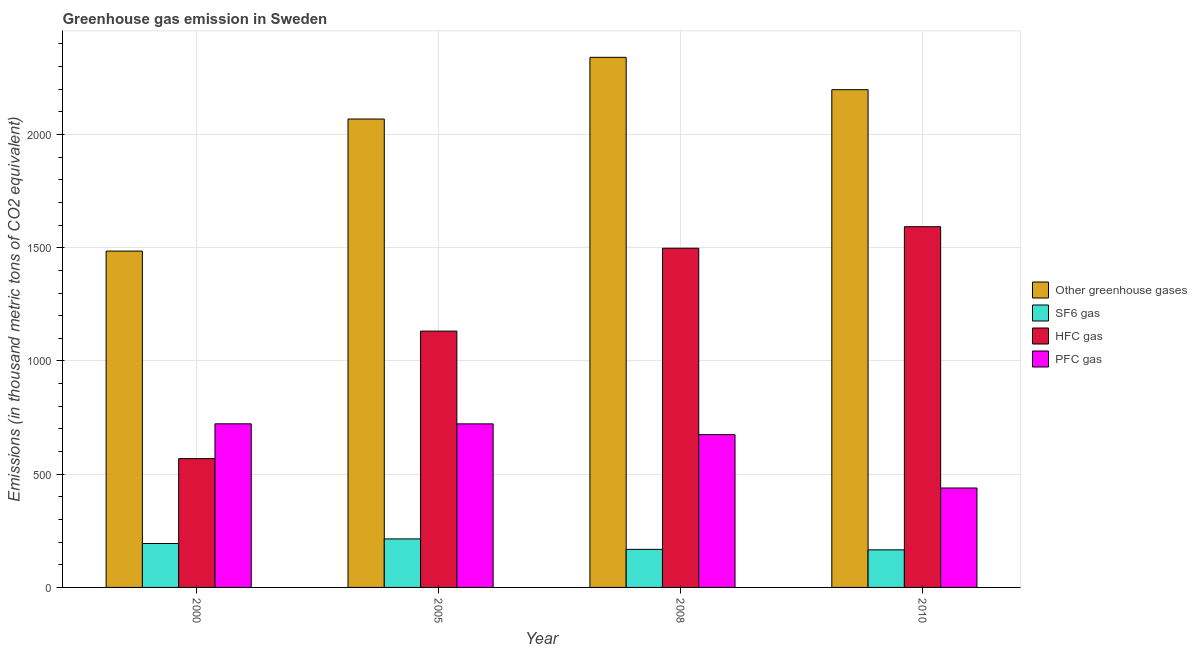How many different coloured bars are there?
Provide a short and direct response. 4. How many groups of bars are there?
Offer a very short reply. 4. Are the number of bars on each tick of the X-axis equal?
Keep it short and to the point. Yes. What is the emission of pfc gas in 2008?
Your answer should be very brief. 674.8. Across all years, what is the maximum emission of pfc gas?
Provide a succinct answer. 722.5. Across all years, what is the minimum emission of pfc gas?
Make the answer very short. 439. In which year was the emission of hfc gas maximum?
Provide a short and direct response. 2010. In which year was the emission of hfc gas minimum?
Ensure brevity in your answer.  2000. What is the total emission of hfc gas in the graph?
Your answer should be compact. 4791.7. What is the difference between the emission of greenhouse gases in 2000 and that in 2005?
Provide a short and direct response. -583.1. What is the difference between the emission of pfc gas in 2005 and the emission of sf6 gas in 2008?
Give a very brief answer. 47.5. What is the average emission of greenhouse gases per year?
Offer a terse response. 2023.15. In the year 2010, what is the difference between the emission of pfc gas and emission of sf6 gas?
Offer a terse response. 0. What is the ratio of the emission of greenhouse gases in 2008 to that in 2010?
Your response must be concise. 1.07. Is the emission of greenhouse gases in 2008 less than that in 2010?
Your answer should be very brief. No. Is the difference between the emission of pfc gas in 2000 and 2008 greater than the difference between the emission of hfc gas in 2000 and 2008?
Make the answer very short. No. What is the difference between the highest and the second highest emission of greenhouse gases?
Your answer should be very brief. 142.9. What is the difference between the highest and the lowest emission of pfc gas?
Your response must be concise. 283.5. In how many years, is the emission of hfc gas greater than the average emission of hfc gas taken over all years?
Ensure brevity in your answer.  2. Is the sum of the emission of hfc gas in 2000 and 2008 greater than the maximum emission of greenhouse gases across all years?
Provide a succinct answer. Yes. What does the 4th bar from the left in 2010 represents?
Offer a very short reply. PFC gas. What does the 1st bar from the right in 2000 represents?
Ensure brevity in your answer.  PFC gas. How many bars are there?
Ensure brevity in your answer.  16. Are all the bars in the graph horizontal?
Offer a terse response. No. Does the graph contain grids?
Ensure brevity in your answer.  Yes. What is the title of the graph?
Provide a succinct answer. Greenhouse gas emission in Sweden. What is the label or title of the X-axis?
Offer a terse response. Year. What is the label or title of the Y-axis?
Your answer should be compact. Emissions (in thousand metric tons of CO2 equivalent). What is the Emissions (in thousand metric tons of CO2 equivalent) of Other greenhouse gases in 2000?
Your response must be concise. 1485.3. What is the Emissions (in thousand metric tons of CO2 equivalent) of SF6 gas in 2000?
Your answer should be compact. 194. What is the Emissions (in thousand metric tons of CO2 equivalent) in HFC gas in 2000?
Your answer should be very brief. 568.8. What is the Emissions (in thousand metric tons of CO2 equivalent) of PFC gas in 2000?
Offer a terse response. 722.5. What is the Emissions (in thousand metric tons of CO2 equivalent) in Other greenhouse gases in 2005?
Your answer should be compact. 2068.4. What is the Emissions (in thousand metric tons of CO2 equivalent) in SF6 gas in 2005?
Make the answer very short. 214.2. What is the Emissions (in thousand metric tons of CO2 equivalent) in HFC gas in 2005?
Keep it short and to the point. 1131.9. What is the Emissions (in thousand metric tons of CO2 equivalent) in PFC gas in 2005?
Your response must be concise. 722.3. What is the Emissions (in thousand metric tons of CO2 equivalent) in Other greenhouse gases in 2008?
Give a very brief answer. 2340.9. What is the Emissions (in thousand metric tons of CO2 equivalent) of SF6 gas in 2008?
Provide a short and direct response. 168.1. What is the Emissions (in thousand metric tons of CO2 equivalent) in HFC gas in 2008?
Keep it short and to the point. 1498. What is the Emissions (in thousand metric tons of CO2 equivalent) of PFC gas in 2008?
Offer a terse response. 674.8. What is the Emissions (in thousand metric tons of CO2 equivalent) in Other greenhouse gases in 2010?
Offer a terse response. 2198. What is the Emissions (in thousand metric tons of CO2 equivalent) in SF6 gas in 2010?
Keep it short and to the point. 166. What is the Emissions (in thousand metric tons of CO2 equivalent) in HFC gas in 2010?
Offer a very short reply. 1593. What is the Emissions (in thousand metric tons of CO2 equivalent) of PFC gas in 2010?
Keep it short and to the point. 439. Across all years, what is the maximum Emissions (in thousand metric tons of CO2 equivalent) in Other greenhouse gases?
Offer a terse response. 2340.9. Across all years, what is the maximum Emissions (in thousand metric tons of CO2 equivalent) of SF6 gas?
Provide a short and direct response. 214.2. Across all years, what is the maximum Emissions (in thousand metric tons of CO2 equivalent) of HFC gas?
Offer a very short reply. 1593. Across all years, what is the maximum Emissions (in thousand metric tons of CO2 equivalent) of PFC gas?
Ensure brevity in your answer.  722.5. Across all years, what is the minimum Emissions (in thousand metric tons of CO2 equivalent) in Other greenhouse gases?
Your answer should be very brief. 1485.3. Across all years, what is the minimum Emissions (in thousand metric tons of CO2 equivalent) in SF6 gas?
Keep it short and to the point. 166. Across all years, what is the minimum Emissions (in thousand metric tons of CO2 equivalent) of HFC gas?
Keep it short and to the point. 568.8. Across all years, what is the minimum Emissions (in thousand metric tons of CO2 equivalent) in PFC gas?
Your answer should be very brief. 439. What is the total Emissions (in thousand metric tons of CO2 equivalent) of Other greenhouse gases in the graph?
Ensure brevity in your answer.  8092.6. What is the total Emissions (in thousand metric tons of CO2 equivalent) in SF6 gas in the graph?
Offer a terse response. 742.3. What is the total Emissions (in thousand metric tons of CO2 equivalent) of HFC gas in the graph?
Provide a short and direct response. 4791.7. What is the total Emissions (in thousand metric tons of CO2 equivalent) in PFC gas in the graph?
Offer a very short reply. 2558.6. What is the difference between the Emissions (in thousand metric tons of CO2 equivalent) in Other greenhouse gases in 2000 and that in 2005?
Give a very brief answer. -583.1. What is the difference between the Emissions (in thousand metric tons of CO2 equivalent) of SF6 gas in 2000 and that in 2005?
Make the answer very short. -20.2. What is the difference between the Emissions (in thousand metric tons of CO2 equivalent) in HFC gas in 2000 and that in 2005?
Make the answer very short. -563.1. What is the difference between the Emissions (in thousand metric tons of CO2 equivalent) of PFC gas in 2000 and that in 2005?
Provide a succinct answer. 0.2. What is the difference between the Emissions (in thousand metric tons of CO2 equivalent) in Other greenhouse gases in 2000 and that in 2008?
Your answer should be compact. -855.6. What is the difference between the Emissions (in thousand metric tons of CO2 equivalent) of SF6 gas in 2000 and that in 2008?
Your answer should be very brief. 25.9. What is the difference between the Emissions (in thousand metric tons of CO2 equivalent) in HFC gas in 2000 and that in 2008?
Provide a short and direct response. -929.2. What is the difference between the Emissions (in thousand metric tons of CO2 equivalent) of PFC gas in 2000 and that in 2008?
Keep it short and to the point. 47.7. What is the difference between the Emissions (in thousand metric tons of CO2 equivalent) in Other greenhouse gases in 2000 and that in 2010?
Give a very brief answer. -712.7. What is the difference between the Emissions (in thousand metric tons of CO2 equivalent) of SF6 gas in 2000 and that in 2010?
Your answer should be very brief. 28. What is the difference between the Emissions (in thousand metric tons of CO2 equivalent) of HFC gas in 2000 and that in 2010?
Give a very brief answer. -1024.2. What is the difference between the Emissions (in thousand metric tons of CO2 equivalent) of PFC gas in 2000 and that in 2010?
Your response must be concise. 283.5. What is the difference between the Emissions (in thousand metric tons of CO2 equivalent) of Other greenhouse gases in 2005 and that in 2008?
Keep it short and to the point. -272.5. What is the difference between the Emissions (in thousand metric tons of CO2 equivalent) of SF6 gas in 2005 and that in 2008?
Ensure brevity in your answer.  46.1. What is the difference between the Emissions (in thousand metric tons of CO2 equivalent) in HFC gas in 2005 and that in 2008?
Give a very brief answer. -366.1. What is the difference between the Emissions (in thousand metric tons of CO2 equivalent) in PFC gas in 2005 and that in 2008?
Keep it short and to the point. 47.5. What is the difference between the Emissions (in thousand metric tons of CO2 equivalent) of Other greenhouse gases in 2005 and that in 2010?
Offer a terse response. -129.6. What is the difference between the Emissions (in thousand metric tons of CO2 equivalent) in SF6 gas in 2005 and that in 2010?
Your answer should be compact. 48.2. What is the difference between the Emissions (in thousand metric tons of CO2 equivalent) of HFC gas in 2005 and that in 2010?
Provide a short and direct response. -461.1. What is the difference between the Emissions (in thousand metric tons of CO2 equivalent) of PFC gas in 2005 and that in 2010?
Provide a short and direct response. 283.3. What is the difference between the Emissions (in thousand metric tons of CO2 equivalent) in Other greenhouse gases in 2008 and that in 2010?
Your answer should be very brief. 142.9. What is the difference between the Emissions (in thousand metric tons of CO2 equivalent) in HFC gas in 2008 and that in 2010?
Ensure brevity in your answer.  -95. What is the difference between the Emissions (in thousand metric tons of CO2 equivalent) of PFC gas in 2008 and that in 2010?
Your response must be concise. 235.8. What is the difference between the Emissions (in thousand metric tons of CO2 equivalent) in Other greenhouse gases in 2000 and the Emissions (in thousand metric tons of CO2 equivalent) in SF6 gas in 2005?
Ensure brevity in your answer.  1271.1. What is the difference between the Emissions (in thousand metric tons of CO2 equivalent) of Other greenhouse gases in 2000 and the Emissions (in thousand metric tons of CO2 equivalent) of HFC gas in 2005?
Provide a succinct answer. 353.4. What is the difference between the Emissions (in thousand metric tons of CO2 equivalent) of Other greenhouse gases in 2000 and the Emissions (in thousand metric tons of CO2 equivalent) of PFC gas in 2005?
Offer a very short reply. 763. What is the difference between the Emissions (in thousand metric tons of CO2 equivalent) of SF6 gas in 2000 and the Emissions (in thousand metric tons of CO2 equivalent) of HFC gas in 2005?
Provide a succinct answer. -937.9. What is the difference between the Emissions (in thousand metric tons of CO2 equivalent) of SF6 gas in 2000 and the Emissions (in thousand metric tons of CO2 equivalent) of PFC gas in 2005?
Keep it short and to the point. -528.3. What is the difference between the Emissions (in thousand metric tons of CO2 equivalent) in HFC gas in 2000 and the Emissions (in thousand metric tons of CO2 equivalent) in PFC gas in 2005?
Ensure brevity in your answer.  -153.5. What is the difference between the Emissions (in thousand metric tons of CO2 equivalent) of Other greenhouse gases in 2000 and the Emissions (in thousand metric tons of CO2 equivalent) of SF6 gas in 2008?
Offer a very short reply. 1317.2. What is the difference between the Emissions (in thousand metric tons of CO2 equivalent) in Other greenhouse gases in 2000 and the Emissions (in thousand metric tons of CO2 equivalent) in HFC gas in 2008?
Keep it short and to the point. -12.7. What is the difference between the Emissions (in thousand metric tons of CO2 equivalent) of Other greenhouse gases in 2000 and the Emissions (in thousand metric tons of CO2 equivalent) of PFC gas in 2008?
Your answer should be very brief. 810.5. What is the difference between the Emissions (in thousand metric tons of CO2 equivalent) of SF6 gas in 2000 and the Emissions (in thousand metric tons of CO2 equivalent) of HFC gas in 2008?
Your answer should be very brief. -1304. What is the difference between the Emissions (in thousand metric tons of CO2 equivalent) in SF6 gas in 2000 and the Emissions (in thousand metric tons of CO2 equivalent) in PFC gas in 2008?
Your answer should be very brief. -480.8. What is the difference between the Emissions (in thousand metric tons of CO2 equivalent) of HFC gas in 2000 and the Emissions (in thousand metric tons of CO2 equivalent) of PFC gas in 2008?
Your answer should be very brief. -106. What is the difference between the Emissions (in thousand metric tons of CO2 equivalent) in Other greenhouse gases in 2000 and the Emissions (in thousand metric tons of CO2 equivalent) in SF6 gas in 2010?
Make the answer very short. 1319.3. What is the difference between the Emissions (in thousand metric tons of CO2 equivalent) in Other greenhouse gases in 2000 and the Emissions (in thousand metric tons of CO2 equivalent) in HFC gas in 2010?
Offer a terse response. -107.7. What is the difference between the Emissions (in thousand metric tons of CO2 equivalent) in Other greenhouse gases in 2000 and the Emissions (in thousand metric tons of CO2 equivalent) in PFC gas in 2010?
Ensure brevity in your answer.  1046.3. What is the difference between the Emissions (in thousand metric tons of CO2 equivalent) of SF6 gas in 2000 and the Emissions (in thousand metric tons of CO2 equivalent) of HFC gas in 2010?
Your answer should be very brief. -1399. What is the difference between the Emissions (in thousand metric tons of CO2 equivalent) in SF6 gas in 2000 and the Emissions (in thousand metric tons of CO2 equivalent) in PFC gas in 2010?
Your answer should be compact. -245. What is the difference between the Emissions (in thousand metric tons of CO2 equivalent) in HFC gas in 2000 and the Emissions (in thousand metric tons of CO2 equivalent) in PFC gas in 2010?
Give a very brief answer. 129.8. What is the difference between the Emissions (in thousand metric tons of CO2 equivalent) of Other greenhouse gases in 2005 and the Emissions (in thousand metric tons of CO2 equivalent) of SF6 gas in 2008?
Make the answer very short. 1900.3. What is the difference between the Emissions (in thousand metric tons of CO2 equivalent) of Other greenhouse gases in 2005 and the Emissions (in thousand metric tons of CO2 equivalent) of HFC gas in 2008?
Keep it short and to the point. 570.4. What is the difference between the Emissions (in thousand metric tons of CO2 equivalent) of Other greenhouse gases in 2005 and the Emissions (in thousand metric tons of CO2 equivalent) of PFC gas in 2008?
Offer a terse response. 1393.6. What is the difference between the Emissions (in thousand metric tons of CO2 equivalent) of SF6 gas in 2005 and the Emissions (in thousand metric tons of CO2 equivalent) of HFC gas in 2008?
Ensure brevity in your answer.  -1283.8. What is the difference between the Emissions (in thousand metric tons of CO2 equivalent) of SF6 gas in 2005 and the Emissions (in thousand metric tons of CO2 equivalent) of PFC gas in 2008?
Ensure brevity in your answer.  -460.6. What is the difference between the Emissions (in thousand metric tons of CO2 equivalent) of HFC gas in 2005 and the Emissions (in thousand metric tons of CO2 equivalent) of PFC gas in 2008?
Keep it short and to the point. 457.1. What is the difference between the Emissions (in thousand metric tons of CO2 equivalent) of Other greenhouse gases in 2005 and the Emissions (in thousand metric tons of CO2 equivalent) of SF6 gas in 2010?
Your answer should be compact. 1902.4. What is the difference between the Emissions (in thousand metric tons of CO2 equivalent) of Other greenhouse gases in 2005 and the Emissions (in thousand metric tons of CO2 equivalent) of HFC gas in 2010?
Provide a succinct answer. 475.4. What is the difference between the Emissions (in thousand metric tons of CO2 equivalent) of Other greenhouse gases in 2005 and the Emissions (in thousand metric tons of CO2 equivalent) of PFC gas in 2010?
Provide a short and direct response. 1629.4. What is the difference between the Emissions (in thousand metric tons of CO2 equivalent) in SF6 gas in 2005 and the Emissions (in thousand metric tons of CO2 equivalent) in HFC gas in 2010?
Offer a very short reply. -1378.8. What is the difference between the Emissions (in thousand metric tons of CO2 equivalent) of SF6 gas in 2005 and the Emissions (in thousand metric tons of CO2 equivalent) of PFC gas in 2010?
Your response must be concise. -224.8. What is the difference between the Emissions (in thousand metric tons of CO2 equivalent) in HFC gas in 2005 and the Emissions (in thousand metric tons of CO2 equivalent) in PFC gas in 2010?
Make the answer very short. 692.9. What is the difference between the Emissions (in thousand metric tons of CO2 equivalent) in Other greenhouse gases in 2008 and the Emissions (in thousand metric tons of CO2 equivalent) in SF6 gas in 2010?
Your answer should be very brief. 2174.9. What is the difference between the Emissions (in thousand metric tons of CO2 equivalent) in Other greenhouse gases in 2008 and the Emissions (in thousand metric tons of CO2 equivalent) in HFC gas in 2010?
Give a very brief answer. 747.9. What is the difference between the Emissions (in thousand metric tons of CO2 equivalent) of Other greenhouse gases in 2008 and the Emissions (in thousand metric tons of CO2 equivalent) of PFC gas in 2010?
Make the answer very short. 1901.9. What is the difference between the Emissions (in thousand metric tons of CO2 equivalent) of SF6 gas in 2008 and the Emissions (in thousand metric tons of CO2 equivalent) of HFC gas in 2010?
Offer a very short reply. -1424.9. What is the difference between the Emissions (in thousand metric tons of CO2 equivalent) in SF6 gas in 2008 and the Emissions (in thousand metric tons of CO2 equivalent) in PFC gas in 2010?
Provide a short and direct response. -270.9. What is the difference between the Emissions (in thousand metric tons of CO2 equivalent) in HFC gas in 2008 and the Emissions (in thousand metric tons of CO2 equivalent) in PFC gas in 2010?
Your answer should be very brief. 1059. What is the average Emissions (in thousand metric tons of CO2 equivalent) of Other greenhouse gases per year?
Your response must be concise. 2023.15. What is the average Emissions (in thousand metric tons of CO2 equivalent) in SF6 gas per year?
Make the answer very short. 185.57. What is the average Emissions (in thousand metric tons of CO2 equivalent) in HFC gas per year?
Give a very brief answer. 1197.92. What is the average Emissions (in thousand metric tons of CO2 equivalent) of PFC gas per year?
Ensure brevity in your answer.  639.65. In the year 2000, what is the difference between the Emissions (in thousand metric tons of CO2 equivalent) of Other greenhouse gases and Emissions (in thousand metric tons of CO2 equivalent) of SF6 gas?
Keep it short and to the point. 1291.3. In the year 2000, what is the difference between the Emissions (in thousand metric tons of CO2 equivalent) in Other greenhouse gases and Emissions (in thousand metric tons of CO2 equivalent) in HFC gas?
Make the answer very short. 916.5. In the year 2000, what is the difference between the Emissions (in thousand metric tons of CO2 equivalent) of Other greenhouse gases and Emissions (in thousand metric tons of CO2 equivalent) of PFC gas?
Ensure brevity in your answer.  762.8. In the year 2000, what is the difference between the Emissions (in thousand metric tons of CO2 equivalent) of SF6 gas and Emissions (in thousand metric tons of CO2 equivalent) of HFC gas?
Your answer should be very brief. -374.8. In the year 2000, what is the difference between the Emissions (in thousand metric tons of CO2 equivalent) in SF6 gas and Emissions (in thousand metric tons of CO2 equivalent) in PFC gas?
Your answer should be compact. -528.5. In the year 2000, what is the difference between the Emissions (in thousand metric tons of CO2 equivalent) of HFC gas and Emissions (in thousand metric tons of CO2 equivalent) of PFC gas?
Provide a succinct answer. -153.7. In the year 2005, what is the difference between the Emissions (in thousand metric tons of CO2 equivalent) in Other greenhouse gases and Emissions (in thousand metric tons of CO2 equivalent) in SF6 gas?
Your answer should be very brief. 1854.2. In the year 2005, what is the difference between the Emissions (in thousand metric tons of CO2 equivalent) of Other greenhouse gases and Emissions (in thousand metric tons of CO2 equivalent) of HFC gas?
Offer a terse response. 936.5. In the year 2005, what is the difference between the Emissions (in thousand metric tons of CO2 equivalent) in Other greenhouse gases and Emissions (in thousand metric tons of CO2 equivalent) in PFC gas?
Your answer should be very brief. 1346.1. In the year 2005, what is the difference between the Emissions (in thousand metric tons of CO2 equivalent) of SF6 gas and Emissions (in thousand metric tons of CO2 equivalent) of HFC gas?
Provide a short and direct response. -917.7. In the year 2005, what is the difference between the Emissions (in thousand metric tons of CO2 equivalent) in SF6 gas and Emissions (in thousand metric tons of CO2 equivalent) in PFC gas?
Your answer should be very brief. -508.1. In the year 2005, what is the difference between the Emissions (in thousand metric tons of CO2 equivalent) in HFC gas and Emissions (in thousand metric tons of CO2 equivalent) in PFC gas?
Offer a terse response. 409.6. In the year 2008, what is the difference between the Emissions (in thousand metric tons of CO2 equivalent) of Other greenhouse gases and Emissions (in thousand metric tons of CO2 equivalent) of SF6 gas?
Offer a very short reply. 2172.8. In the year 2008, what is the difference between the Emissions (in thousand metric tons of CO2 equivalent) in Other greenhouse gases and Emissions (in thousand metric tons of CO2 equivalent) in HFC gas?
Offer a terse response. 842.9. In the year 2008, what is the difference between the Emissions (in thousand metric tons of CO2 equivalent) in Other greenhouse gases and Emissions (in thousand metric tons of CO2 equivalent) in PFC gas?
Provide a short and direct response. 1666.1. In the year 2008, what is the difference between the Emissions (in thousand metric tons of CO2 equivalent) of SF6 gas and Emissions (in thousand metric tons of CO2 equivalent) of HFC gas?
Keep it short and to the point. -1329.9. In the year 2008, what is the difference between the Emissions (in thousand metric tons of CO2 equivalent) in SF6 gas and Emissions (in thousand metric tons of CO2 equivalent) in PFC gas?
Your response must be concise. -506.7. In the year 2008, what is the difference between the Emissions (in thousand metric tons of CO2 equivalent) in HFC gas and Emissions (in thousand metric tons of CO2 equivalent) in PFC gas?
Provide a succinct answer. 823.2. In the year 2010, what is the difference between the Emissions (in thousand metric tons of CO2 equivalent) of Other greenhouse gases and Emissions (in thousand metric tons of CO2 equivalent) of SF6 gas?
Keep it short and to the point. 2032. In the year 2010, what is the difference between the Emissions (in thousand metric tons of CO2 equivalent) of Other greenhouse gases and Emissions (in thousand metric tons of CO2 equivalent) of HFC gas?
Your response must be concise. 605. In the year 2010, what is the difference between the Emissions (in thousand metric tons of CO2 equivalent) in Other greenhouse gases and Emissions (in thousand metric tons of CO2 equivalent) in PFC gas?
Ensure brevity in your answer.  1759. In the year 2010, what is the difference between the Emissions (in thousand metric tons of CO2 equivalent) in SF6 gas and Emissions (in thousand metric tons of CO2 equivalent) in HFC gas?
Provide a succinct answer. -1427. In the year 2010, what is the difference between the Emissions (in thousand metric tons of CO2 equivalent) in SF6 gas and Emissions (in thousand metric tons of CO2 equivalent) in PFC gas?
Offer a very short reply. -273. In the year 2010, what is the difference between the Emissions (in thousand metric tons of CO2 equivalent) of HFC gas and Emissions (in thousand metric tons of CO2 equivalent) of PFC gas?
Offer a very short reply. 1154. What is the ratio of the Emissions (in thousand metric tons of CO2 equivalent) in Other greenhouse gases in 2000 to that in 2005?
Keep it short and to the point. 0.72. What is the ratio of the Emissions (in thousand metric tons of CO2 equivalent) of SF6 gas in 2000 to that in 2005?
Give a very brief answer. 0.91. What is the ratio of the Emissions (in thousand metric tons of CO2 equivalent) in HFC gas in 2000 to that in 2005?
Make the answer very short. 0.5. What is the ratio of the Emissions (in thousand metric tons of CO2 equivalent) of Other greenhouse gases in 2000 to that in 2008?
Your answer should be compact. 0.63. What is the ratio of the Emissions (in thousand metric tons of CO2 equivalent) of SF6 gas in 2000 to that in 2008?
Make the answer very short. 1.15. What is the ratio of the Emissions (in thousand metric tons of CO2 equivalent) of HFC gas in 2000 to that in 2008?
Make the answer very short. 0.38. What is the ratio of the Emissions (in thousand metric tons of CO2 equivalent) of PFC gas in 2000 to that in 2008?
Ensure brevity in your answer.  1.07. What is the ratio of the Emissions (in thousand metric tons of CO2 equivalent) of Other greenhouse gases in 2000 to that in 2010?
Keep it short and to the point. 0.68. What is the ratio of the Emissions (in thousand metric tons of CO2 equivalent) in SF6 gas in 2000 to that in 2010?
Your answer should be compact. 1.17. What is the ratio of the Emissions (in thousand metric tons of CO2 equivalent) in HFC gas in 2000 to that in 2010?
Provide a succinct answer. 0.36. What is the ratio of the Emissions (in thousand metric tons of CO2 equivalent) in PFC gas in 2000 to that in 2010?
Give a very brief answer. 1.65. What is the ratio of the Emissions (in thousand metric tons of CO2 equivalent) in Other greenhouse gases in 2005 to that in 2008?
Provide a short and direct response. 0.88. What is the ratio of the Emissions (in thousand metric tons of CO2 equivalent) in SF6 gas in 2005 to that in 2008?
Your answer should be very brief. 1.27. What is the ratio of the Emissions (in thousand metric tons of CO2 equivalent) in HFC gas in 2005 to that in 2008?
Provide a succinct answer. 0.76. What is the ratio of the Emissions (in thousand metric tons of CO2 equivalent) in PFC gas in 2005 to that in 2008?
Your response must be concise. 1.07. What is the ratio of the Emissions (in thousand metric tons of CO2 equivalent) in Other greenhouse gases in 2005 to that in 2010?
Offer a very short reply. 0.94. What is the ratio of the Emissions (in thousand metric tons of CO2 equivalent) in SF6 gas in 2005 to that in 2010?
Provide a succinct answer. 1.29. What is the ratio of the Emissions (in thousand metric tons of CO2 equivalent) of HFC gas in 2005 to that in 2010?
Offer a terse response. 0.71. What is the ratio of the Emissions (in thousand metric tons of CO2 equivalent) in PFC gas in 2005 to that in 2010?
Your answer should be very brief. 1.65. What is the ratio of the Emissions (in thousand metric tons of CO2 equivalent) in Other greenhouse gases in 2008 to that in 2010?
Offer a terse response. 1.06. What is the ratio of the Emissions (in thousand metric tons of CO2 equivalent) in SF6 gas in 2008 to that in 2010?
Keep it short and to the point. 1.01. What is the ratio of the Emissions (in thousand metric tons of CO2 equivalent) of HFC gas in 2008 to that in 2010?
Provide a short and direct response. 0.94. What is the ratio of the Emissions (in thousand metric tons of CO2 equivalent) of PFC gas in 2008 to that in 2010?
Your answer should be very brief. 1.54. What is the difference between the highest and the second highest Emissions (in thousand metric tons of CO2 equivalent) in Other greenhouse gases?
Provide a short and direct response. 142.9. What is the difference between the highest and the second highest Emissions (in thousand metric tons of CO2 equivalent) of SF6 gas?
Provide a short and direct response. 20.2. What is the difference between the highest and the second highest Emissions (in thousand metric tons of CO2 equivalent) in PFC gas?
Your answer should be compact. 0.2. What is the difference between the highest and the lowest Emissions (in thousand metric tons of CO2 equivalent) of Other greenhouse gases?
Provide a short and direct response. 855.6. What is the difference between the highest and the lowest Emissions (in thousand metric tons of CO2 equivalent) of SF6 gas?
Offer a terse response. 48.2. What is the difference between the highest and the lowest Emissions (in thousand metric tons of CO2 equivalent) in HFC gas?
Your response must be concise. 1024.2. What is the difference between the highest and the lowest Emissions (in thousand metric tons of CO2 equivalent) of PFC gas?
Make the answer very short. 283.5. 